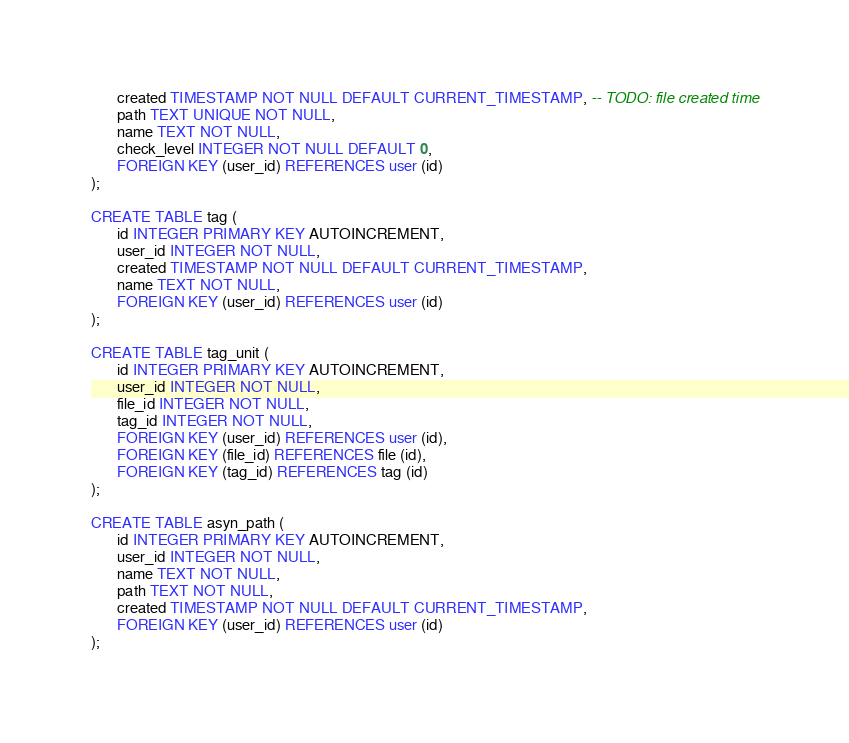<code> <loc_0><loc_0><loc_500><loc_500><_SQL_>       created TIMESTAMP NOT NULL DEFAULT CURRENT_TIMESTAMP, -- TODO: file created time
       path TEXT UNIQUE NOT NULL,
       name TEXT NOT NULL,
       check_level INTEGER NOT NULL DEFAULT 0,
       FOREIGN KEY (user_id) REFERENCES user (id)
);

CREATE TABLE tag (
       id INTEGER PRIMARY KEY AUTOINCREMENT,
       user_id INTEGER NOT NULL,
       created TIMESTAMP NOT NULL DEFAULT CURRENT_TIMESTAMP,	
       name TEXT NOT NULL,
       FOREIGN KEY (user_id) REFERENCES user (id)
);

CREATE TABLE tag_unit (
       id INTEGER PRIMARY KEY AUTOINCREMENT,
       user_id INTEGER NOT NULL,
       file_id INTEGER NOT NULL,
       tag_id INTEGER NOT NULL,
       FOREIGN KEY (user_id) REFERENCES user (id),
       FOREIGN KEY (file_id) REFERENCES file (id),
       FOREIGN KEY (tag_id) REFERENCES tag (id)
);

CREATE TABLE asyn_path (
       id INTEGER PRIMARY KEY AUTOINCREMENT,
       user_id INTEGER NOT NULL,
       name TEXT NOT NULL,
       path TEXT NOT NULL,
       created TIMESTAMP NOT NULL DEFAULT CURRENT_TIMESTAMP,
       FOREIGN KEY (user_id) REFERENCES user (id)
);
</code> 